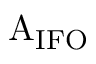Convert formula to latex. <formula><loc_0><loc_0><loc_500><loc_500>A _ { I F O }</formula> 